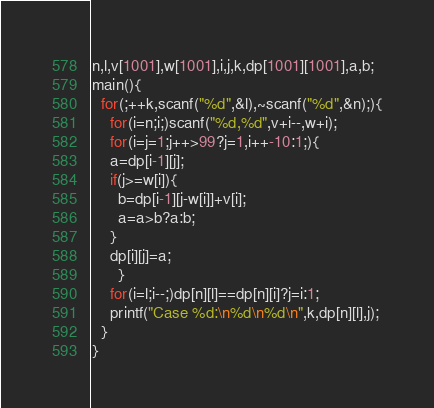<code> <loc_0><loc_0><loc_500><loc_500><_C_>n,l,v[1001],w[1001],i,j,k,dp[1001][1001],a,b;
main(){
  for(;++k,scanf("%d",&l),~scanf("%d",&n);){
    for(i=n;i;)scanf("%d,%d",v+i--,w+i);
    for(i=j=1;j++>99?j=1,i++-10:1;){
	a=dp[i-1][j];
	if(j>=w[i]){
	  b=dp[i-1][j-w[i]]+v[i];
	  a=a>b?a:b;
	}
	dp[i][j]=a;
      }
    for(i=l;i--;)dp[n][l]==dp[n][i]?j=i:1;
    printf("Case %d:\n%d\n%d\n",k,dp[n][l],j);
  }
}</code> 